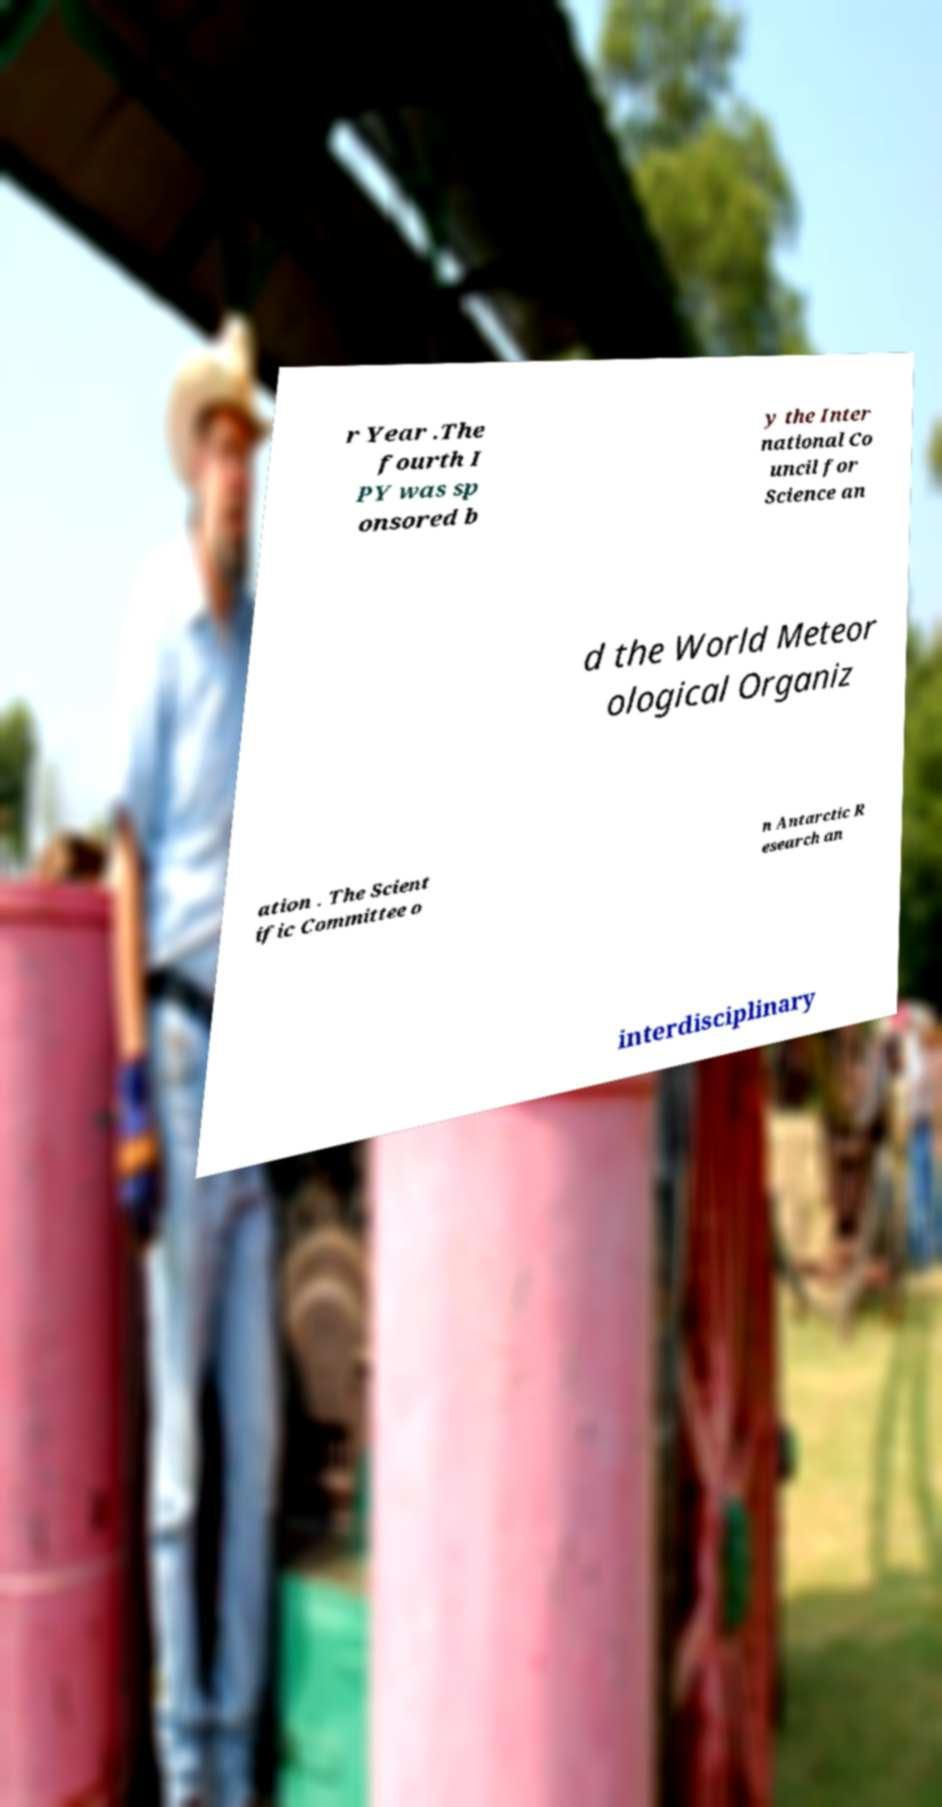There's text embedded in this image that I need extracted. Can you transcribe it verbatim? r Year .The fourth I PY was sp onsored b y the Inter national Co uncil for Science an d the World Meteor ological Organiz ation . The Scient ific Committee o n Antarctic R esearch an interdisciplinary 